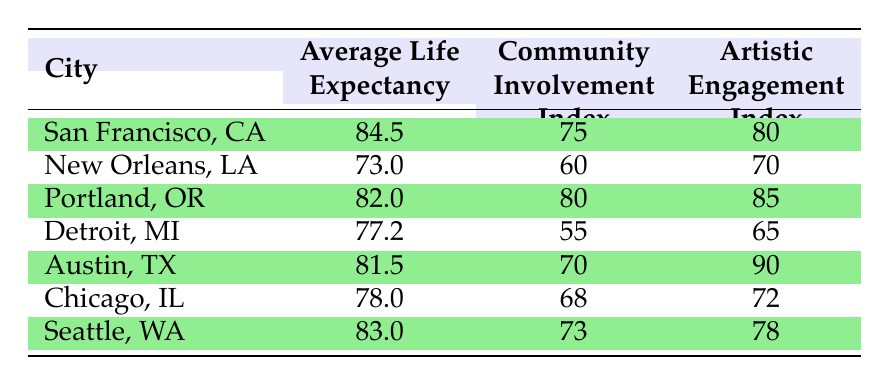What is the average life expectancy in San Francisco, CA? The average life expectancy for San Francisco, CA is directly provided in the table as 84.5 years.
Answer: 84.5 Which city has the lowest community involvement index? By looking at the community involvement index values in the table, Detroit, MI has the lowest value at 55.
Answer: Detroit, MI What is the difference in average life expectancy between Portland, OR and New Orleans, LA? The average life expectancy for Portland, OR is 82.0 and for New Orleans, LA is 73.0. Therefore, the difference is 82.0 - 73.0 = 9.0 years.
Answer: 9.0 Is the artistic engagement index in Austin, TX higher than in Seattle, WA? The artistic engagement index for Austin, TX is 90, while for Seattle, WA it is 78. Since 90 is greater than 78, the statement is true.
Answer: Yes What is the average of the community involvement index for all cities listed in the table? The sum of the community involvement indices is 75 + 60 + 80 + 55 + 70 + 68 + 73 = 481. There are 7 cities, so the average is 481 / 7 = 68.71.
Answer: 68.71 Which city shows the highest artistic engagement index, and what is that index? Looking at the artistic engagement indices, Austin, TX has the highest index at 90.
Answer: Austin, TX, 90 What city has an average life expectancy greater than 80 years? By inspecting the table, the cities with an average life expectancy greater than 80 are San Francisco, CA (84.5), Portland, OR (82.0), and Seattle, WA (83.0).
Answer: San Francisco, CA; Portland, OR; Seattle, WA Is New Orleans, LA's average life expectancy below 75 years? The average life expectancy for New Orleans, LA is 73.0 years, which is indeed below 75 years. Therefore, the answer is true.
Answer: Yes What is the sum of the average life expectancies of Detroit, MI and Chicago, IL? The average life expectancy for Detroit, MI is 77.2, and for Chicago, IL it is 78.0. Summing these gives 77.2 + 78.0 = 155.2.
Answer: 155.2 